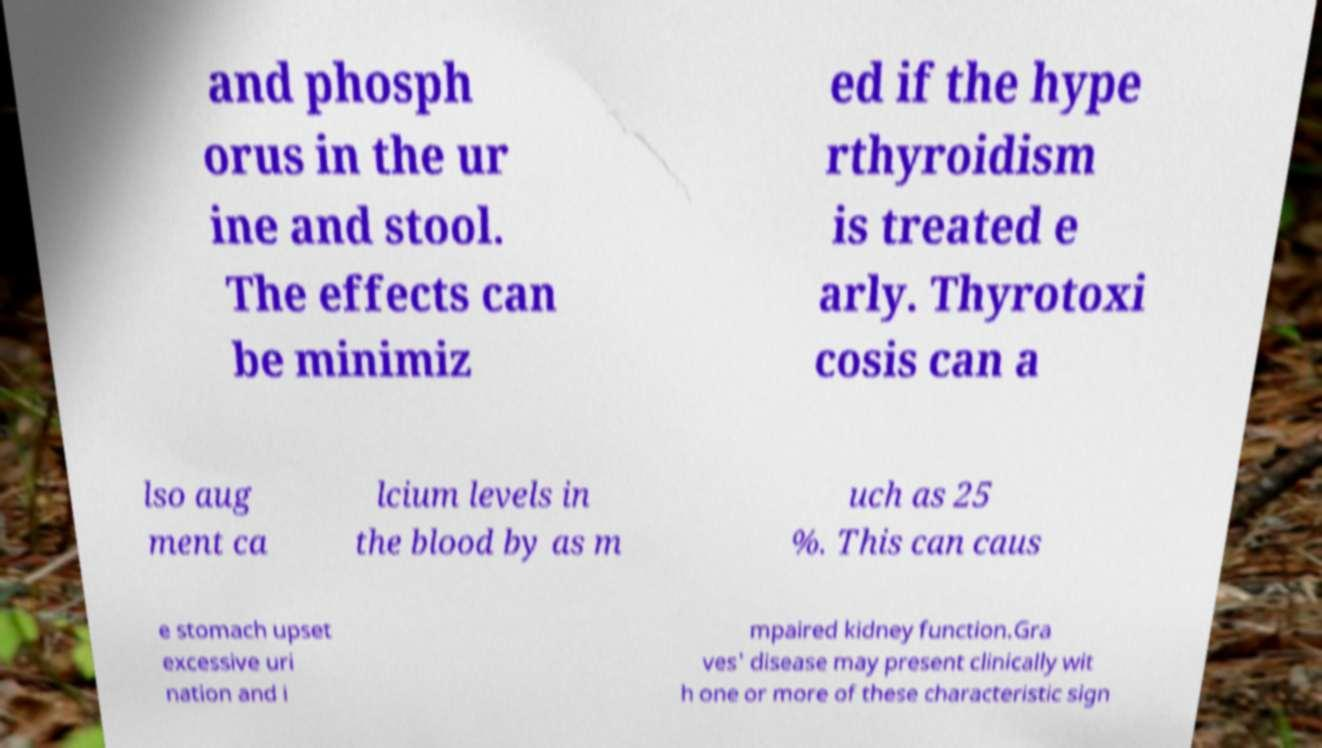Please identify and transcribe the text found in this image. and phosph orus in the ur ine and stool. The effects can be minimiz ed if the hype rthyroidism is treated e arly. Thyrotoxi cosis can a lso aug ment ca lcium levels in the blood by as m uch as 25 %. This can caus e stomach upset excessive uri nation and i mpaired kidney function.Gra ves' disease may present clinically wit h one or more of these characteristic sign 